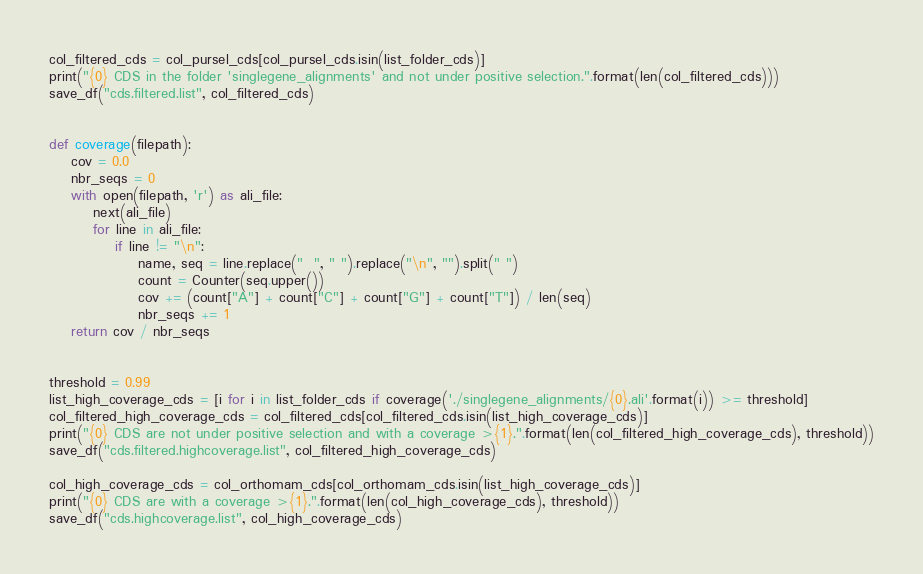<code> <loc_0><loc_0><loc_500><loc_500><_Python_>col_filtered_cds = col_pursel_cds[col_pursel_cds.isin(list_folder_cds)]
print("{0} CDS in the folder 'singlegene_alignments' and not under positive selection.".format(len(col_filtered_cds)))
save_df("cds.filtered.list", col_filtered_cds)


def coverage(filepath):
    cov = 0.0
    nbr_seqs = 0
    with open(filepath, 'r') as ali_file:
        next(ali_file)
        for line in ali_file:
            if line != "\n":
                name, seq = line.replace("  ", " ").replace("\n", "").split(" ")
                count = Counter(seq.upper())
                cov += (count["A"] + count["C"] + count["G"] + count["T"]) / len(seq)
                nbr_seqs += 1
    return cov / nbr_seqs


threshold = 0.99
list_high_coverage_cds = [i for i in list_folder_cds if coverage('./singlegene_alignments/{0}.ali'.format(i)) >= threshold]
col_filtered_high_coverage_cds = col_filtered_cds[col_filtered_cds.isin(list_high_coverage_cds)]
print("{0} CDS are not under positive selection and with a coverage >{1}.".format(len(col_filtered_high_coverage_cds), threshold))
save_df("cds.filtered.highcoverage.list", col_filtered_high_coverage_cds)

col_high_coverage_cds = col_orthomam_cds[col_orthomam_cds.isin(list_high_coverage_cds)]
print("{0} CDS are with a coverage >{1}.".format(len(col_high_coverage_cds), threshold))
save_df("cds.highcoverage.list", col_high_coverage_cds)
</code> 